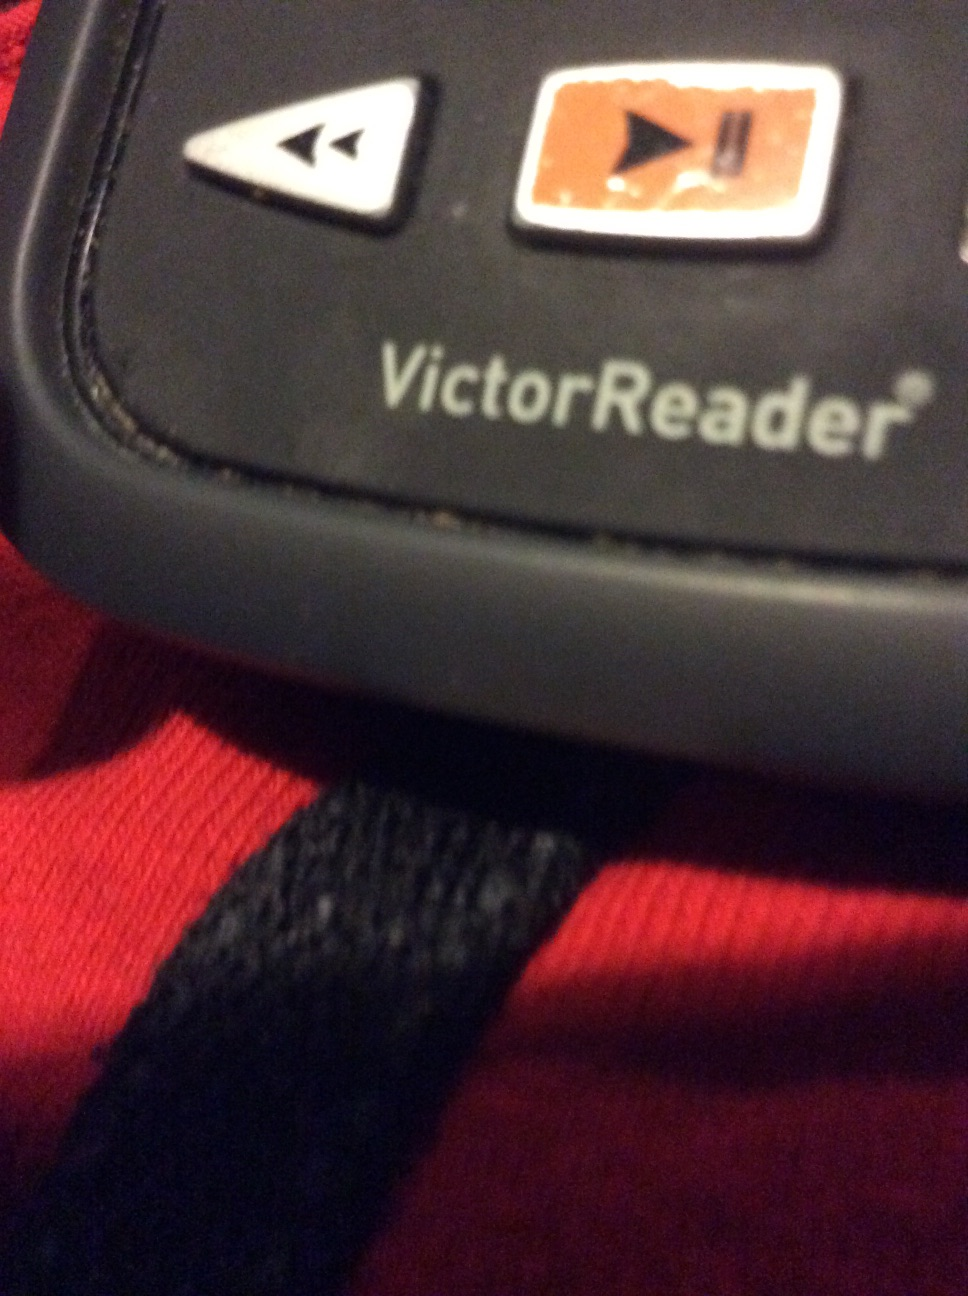Please describe a realistic scenario where this device could significantly improve someone's life in a long response. Imagine an elderly individual living alone who has recently lost their sight. They receive a VictorReader and slowly reacquaint themselves with the joy of reading. Everyday articles, books, and letters that were once inaccessible become part of their daily routine again. The device not only provides them with information but also brings comfort as they listen to their favorite books and stay connected with the world through news articles. It significantly improves their quality of life by renewing a sense of independence and intellectual engagement. 